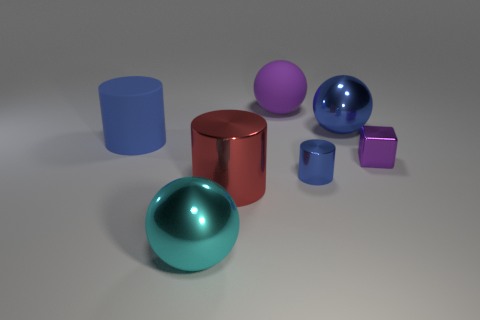Add 2 purple blocks. How many objects exist? 9 Subtract all cubes. How many objects are left? 6 Subtract all large brown metal spheres. Subtract all blue shiny objects. How many objects are left? 5 Add 4 large blue matte things. How many large blue matte things are left? 5 Add 1 small purple objects. How many small purple objects exist? 2 Subtract 0 purple cylinders. How many objects are left? 7 